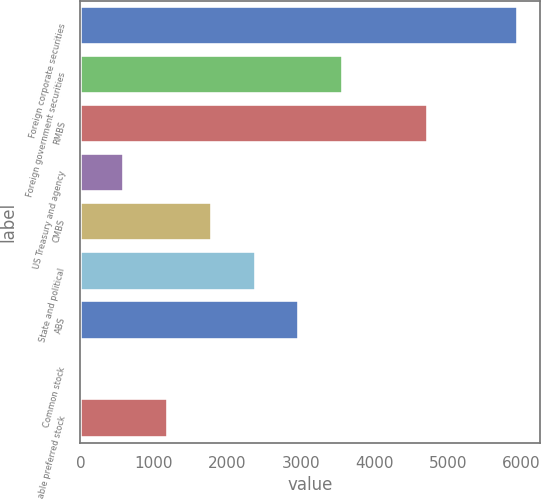<chart> <loc_0><loc_0><loc_500><loc_500><bar_chart><fcel>Foreign corporate securities<fcel>Foreign government securities<fcel>RMBS<fcel>US Treasury and agency<fcel>CMBS<fcel>State and political<fcel>ABS<fcel>Common stock<fcel>Non-redeemable preferred stock<nl><fcel>5957<fcel>3576.2<fcel>4724<fcel>600.2<fcel>1790.6<fcel>2385.8<fcel>2981<fcel>5<fcel>1195.4<nl></chart> 